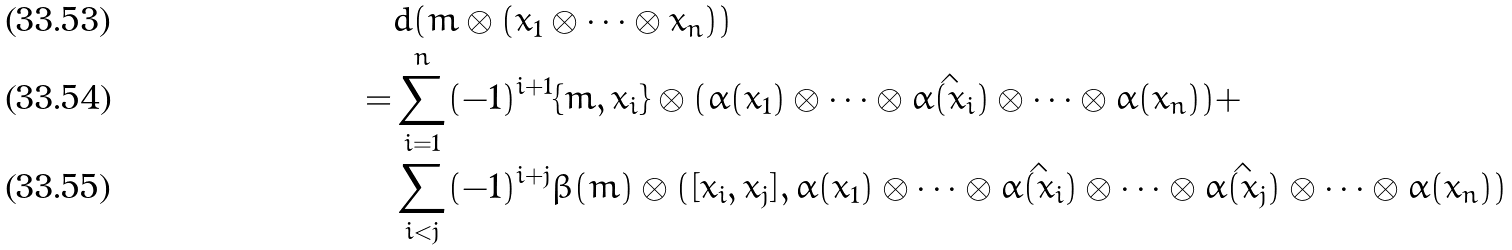<formula> <loc_0><loc_0><loc_500><loc_500>& d ( m \otimes ( x _ { 1 } \otimes \cdots \otimes x _ { n } ) ) \\ = & \sum _ { i = 1 } ^ { n } ( - 1 ) ^ { i + 1 } \{ m , x _ { i } \} \otimes ( \alpha ( x _ { 1 } ) \otimes \cdots \otimes \hat { \alpha ( x _ { i } ) } \otimes \cdots \otimes \alpha ( x _ { n } ) ) + \\ & \sum _ { i < j } ( - 1 ) ^ { i + j } \beta ( m ) \otimes ( [ x _ { i } , x _ { j } ] , \alpha ( x _ { 1 } ) \otimes \cdots \otimes \hat { \alpha ( x _ { i } ) } \otimes \cdots \otimes \hat { \alpha ( x _ { j } ) } \otimes \cdots \otimes \alpha ( x _ { n } ) )</formula> 